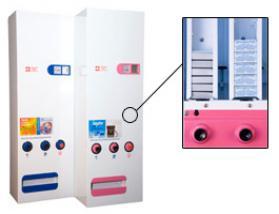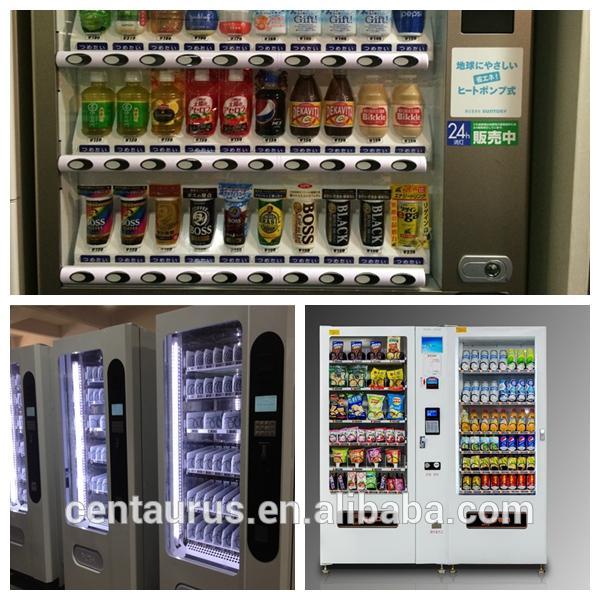The first image is the image on the left, the second image is the image on the right. Assess this claim about the two images: "Right image includes a white vending machine that dispenses beverages.". Correct or not? Answer yes or no. Yes. The first image is the image on the left, the second image is the image on the right. Considering the images on both sides, is "There are multiple vending machines, none of which are in restrooms, and there are no people." valid? Answer yes or no. Yes. 